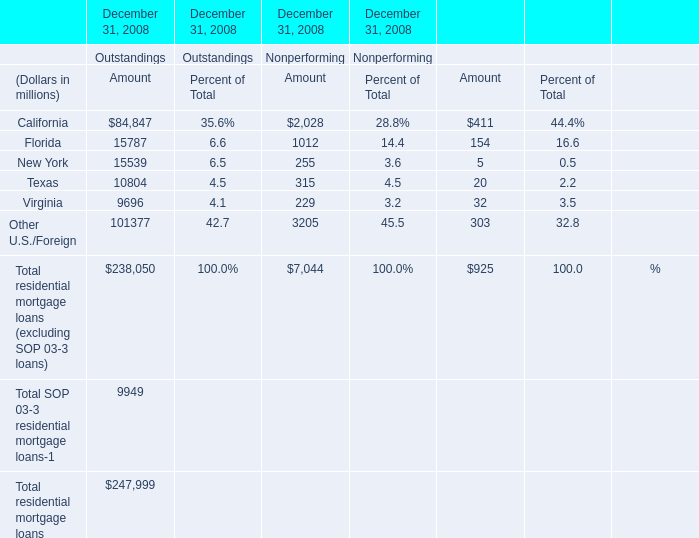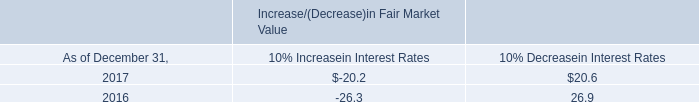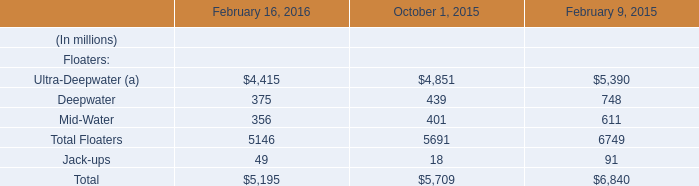What's the average of Outstandings and Nonperforming and Net charpe offs of New York in 2008? (in million) 
Computations: (((15539 + 255) + 5) / 3)
Answer: 5266.33333. 